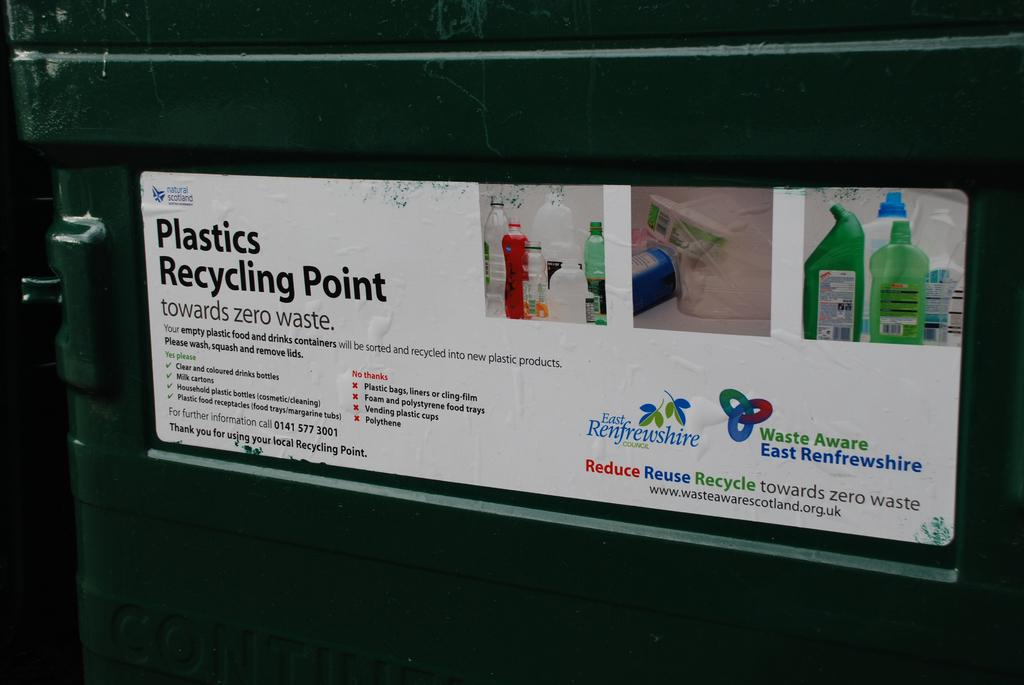Provide a one-sentence caption for the provided image. A recycling bin has a sticker than says Plastics Recycling Point. 